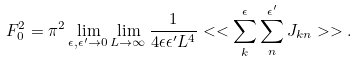<formula> <loc_0><loc_0><loc_500><loc_500>F _ { 0 } ^ { 2 } = { \pi } ^ { 2 } \lim _ { \epsilon , \epsilon ^ { \prime } \to 0 } \lim _ { L \to \infty } \frac { 1 } { 4 \epsilon \epsilon ^ { \prime } L ^ { 4 } } < < \sum _ { k } ^ { \epsilon } \sum _ { n } ^ { \epsilon ^ { \prime } } J _ { k n } > > .</formula> 